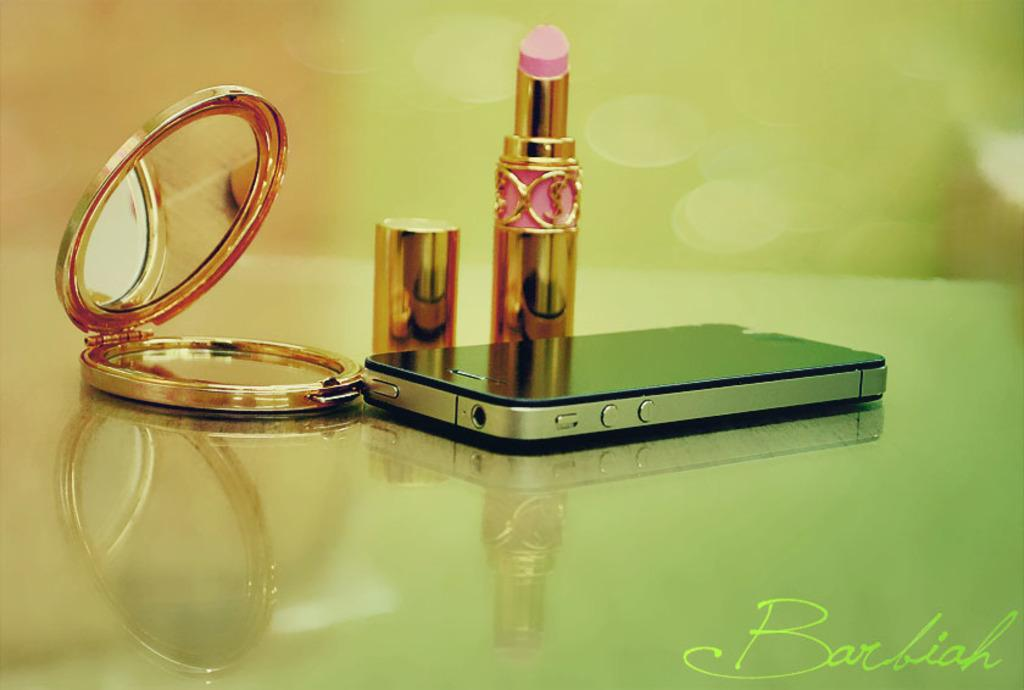What electronic device is visible in the image? There is a mobile phone in the image. What cosmetic item is present in the image? There is a lipstick in the image. Where is the lipstick cap located in relation to the lipstick? The lipstick cap is beside the lipstick. What is used for personal grooming in the image? There is a small mirror in the image. On what surface are the objects placed? The objects are placed on a glass desk. What invention is being demonstrated in the image? There is no invention being demonstrated in the image; it simply shows a mobile phone, lipstick, lipstick cap, small mirror, and a glass desk. How many pencils are visible in the image? There are no pencils present in the image. 